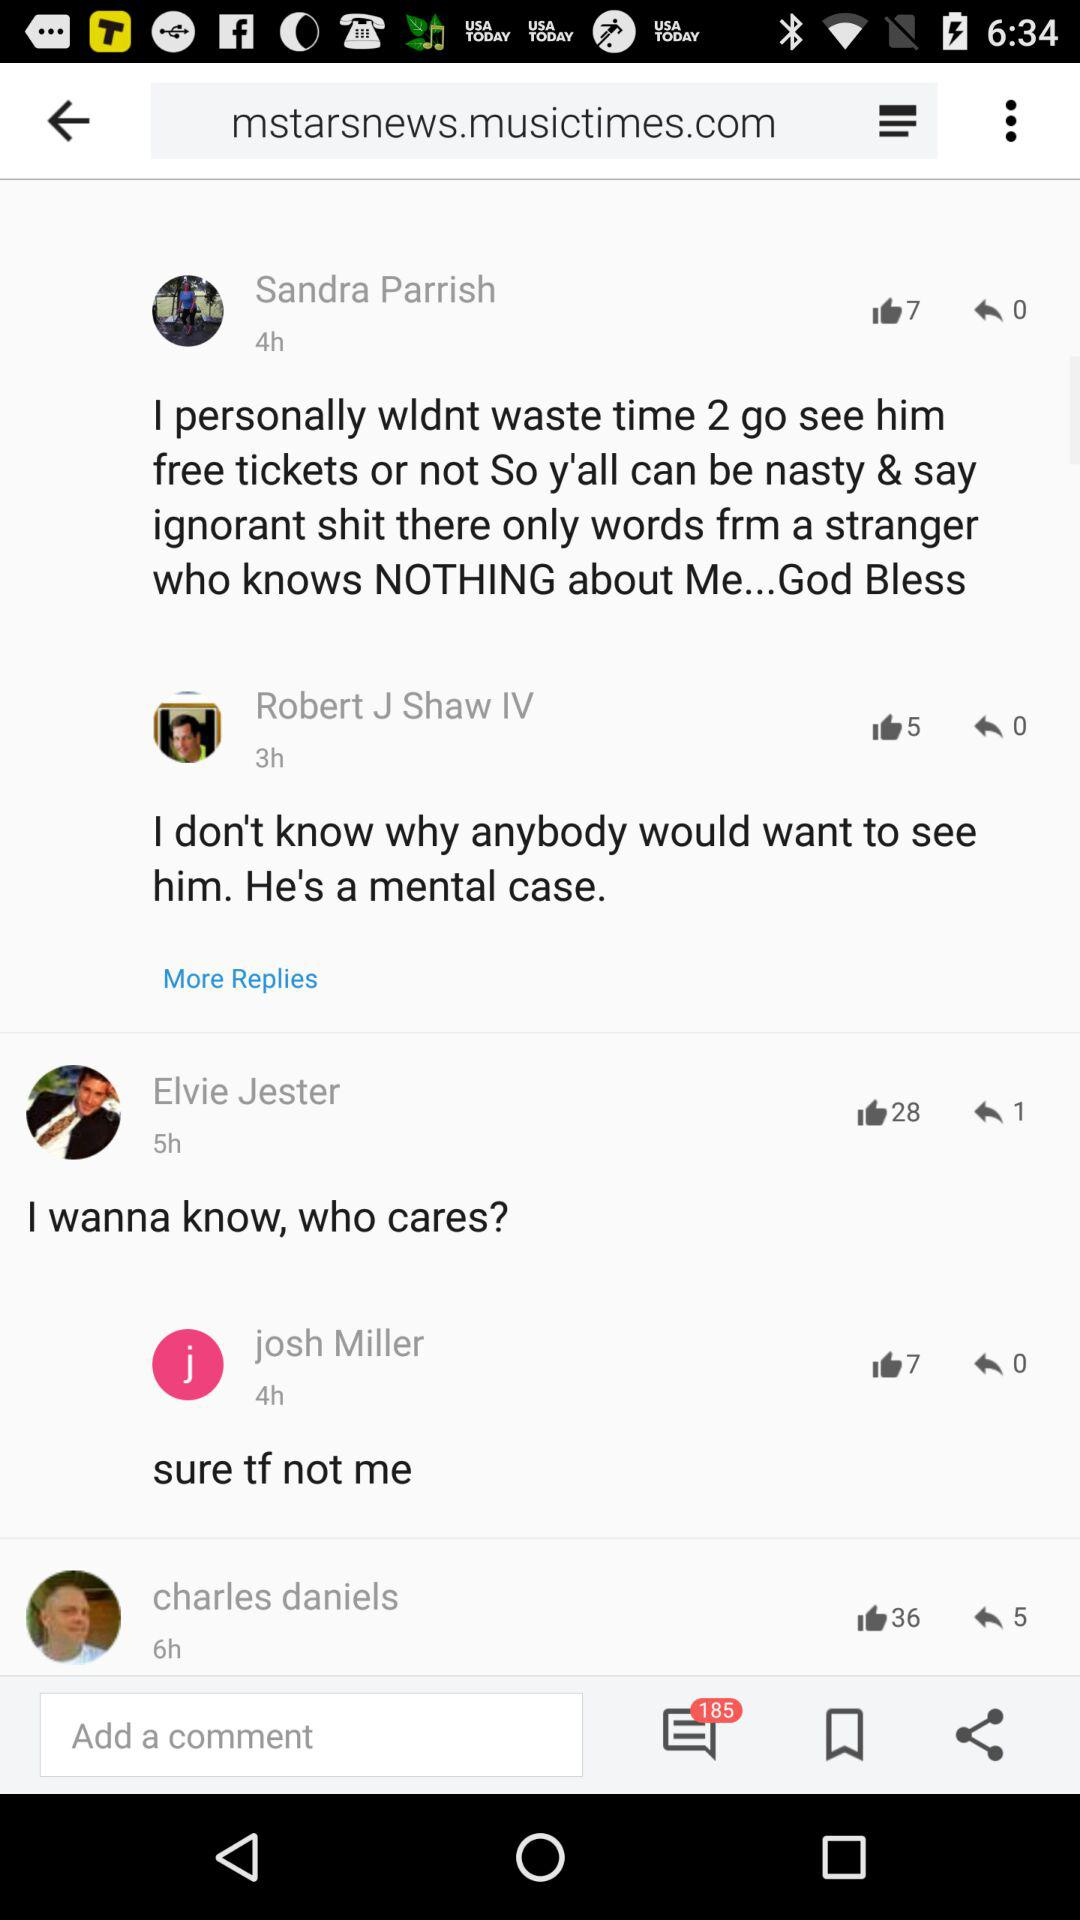What's the number of replies on Elvie Jester's post? The number of replies on Elvie Jester's post is 1. 